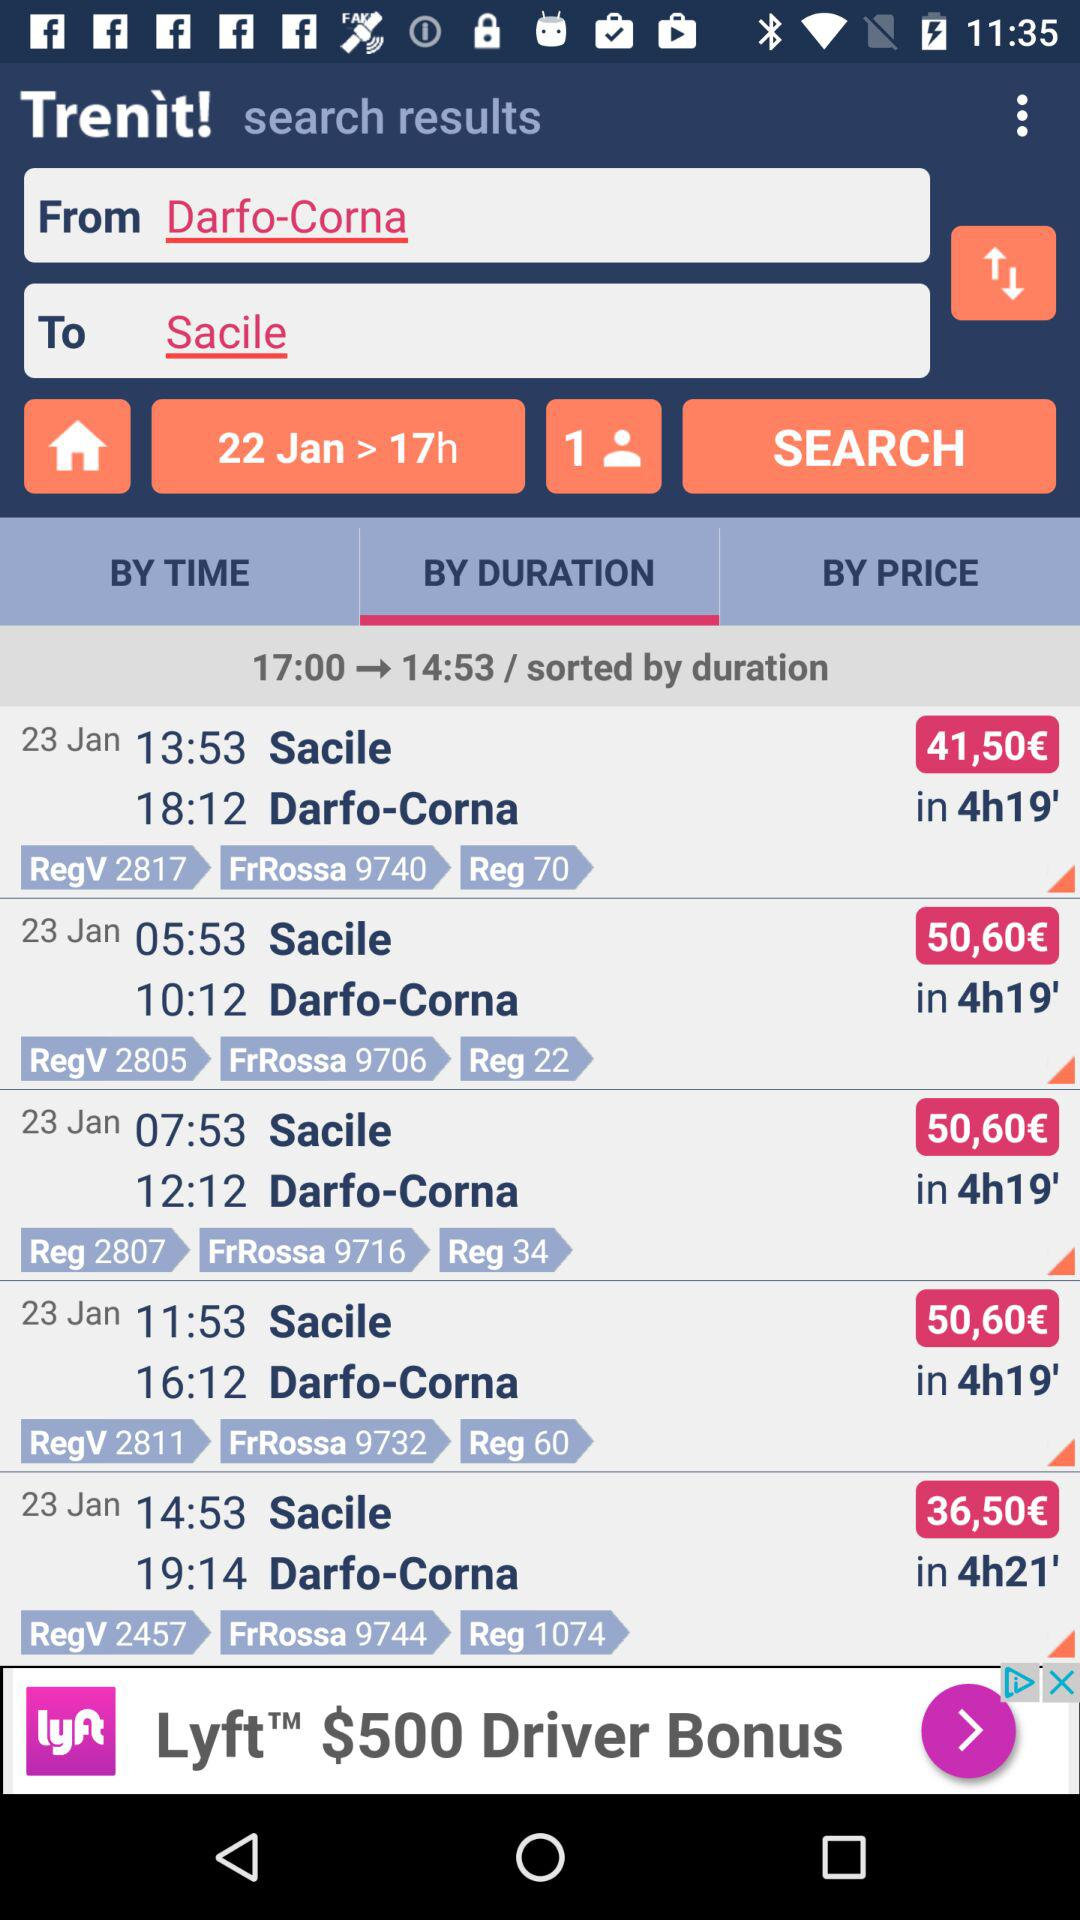What is the journey date? The journey date is January 22. 